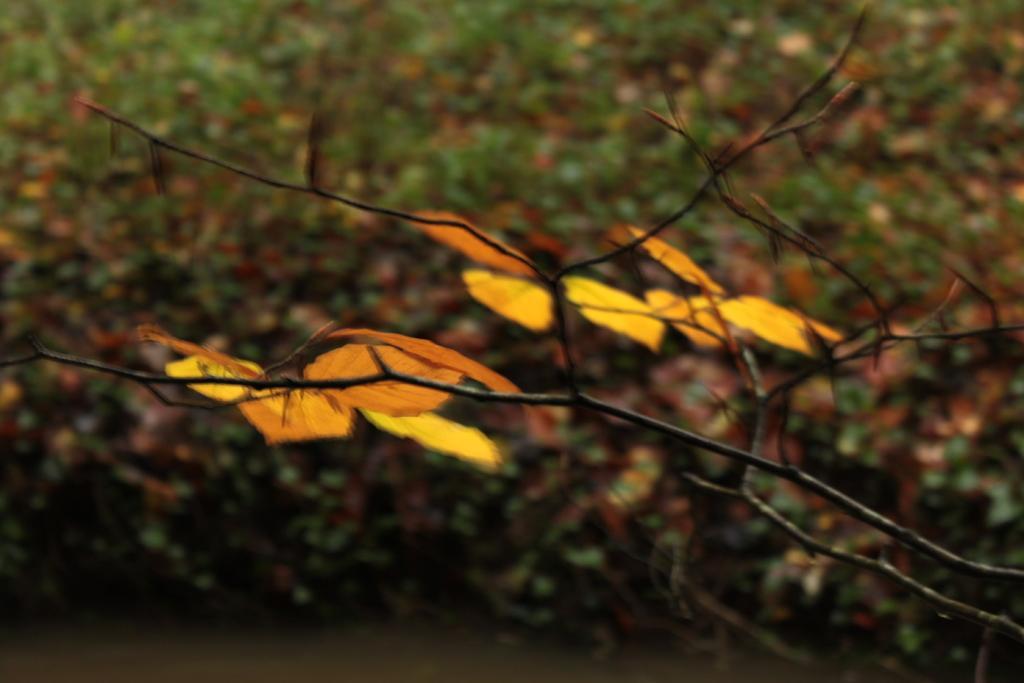How would you summarize this image in a sentence or two? In this image, we can see some plants. There is a branch in the middle of the image. 